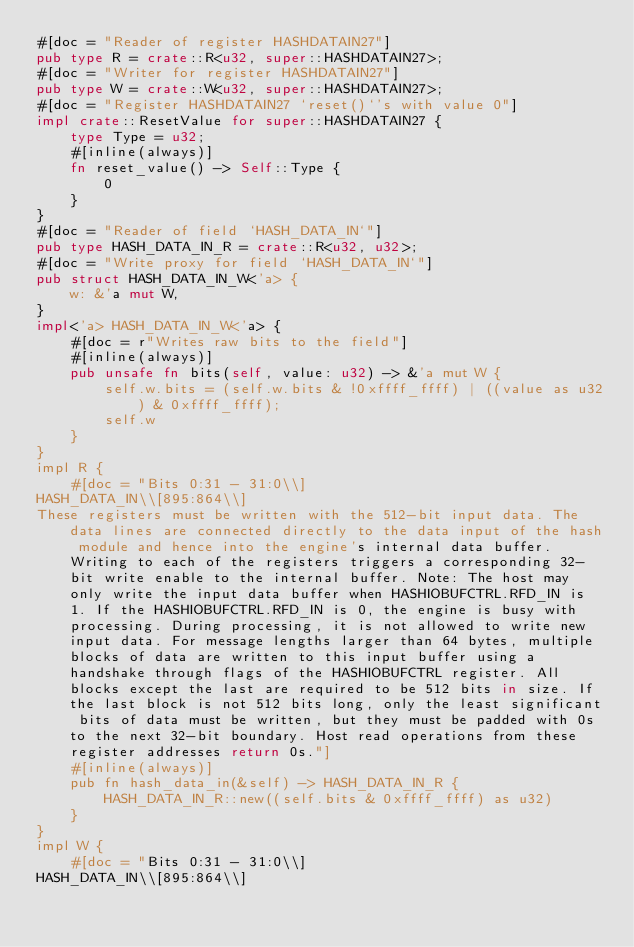Convert code to text. <code><loc_0><loc_0><loc_500><loc_500><_Rust_>#[doc = "Reader of register HASHDATAIN27"]
pub type R = crate::R<u32, super::HASHDATAIN27>;
#[doc = "Writer for register HASHDATAIN27"]
pub type W = crate::W<u32, super::HASHDATAIN27>;
#[doc = "Register HASHDATAIN27 `reset()`'s with value 0"]
impl crate::ResetValue for super::HASHDATAIN27 {
    type Type = u32;
    #[inline(always)]
    fn reset_value() -> Self::Type {
        0
    }
}
#[doc = "Reader of field `HASH_DATA_IN`"]
pub type HASH_DATA_IN_R = crate::R<u32, u32>;
#[doc = "Write proxy for field `HASH_DATA_IN`"]
pub struct HASH_DATA_IN_W<'a> {
    w: &'a mut W,
}
impl<'a> HASH_DATA_IN_W<'a> {
    #[doc = r"Writes raw bits to the field"]
    #[inline(always)]
    pub unsafe fn bits(self, value: u32) -> &'a mut W {
        self.w.bits = (self.w.bits & !0xffff_ffff) | ((value as u32) & 0xffff_ffff);
        self.w
    }
}
impl R {
    #[doc = "Bits 0:31 - 31:0\\]
HASH_DATA_IN\\[895:864\\]
These registers must be written with the 512-bit input data. The data lines are connected directly to the data input of the hash module and hence into the engine's internal data buffer. Writing to each of the registers triggers a corresponding 32-bit write enable to the internal buffer. Note: The host may only write the input data buffer when HASHIOBUFCTRL.RFD_IN is 1. If the HASHIOBUFCTRL.RFD_IN is 0, the engine is busy with processing. During processing, it is not allowed to write new input data. For message lengths larger than 64 bytes, multiple blocks of data are written to this input buffer using a handshake through flags of the HASHIOBUFCTRL register. All blocks except the last are required to be 512 bits in size. If the last block is not 512 bits long, only the least significant bits of data must be written, but they must be padded with 0s to the next 32-bit boundary. Host read operations from these register addresses return 0s."]
    #[inline(always)]
    pub fn hash_data_in(&self) -> HASH_DATA_IN_R {
        HASH_DATA_IN_R::new((self.bits & 0xffff_ffff) as u32)
    }
}
impl W {
    #[doc = "Bits 0:31 - 31:0\\]
HASH_DATA_IN\\[895:864\\]</code> 